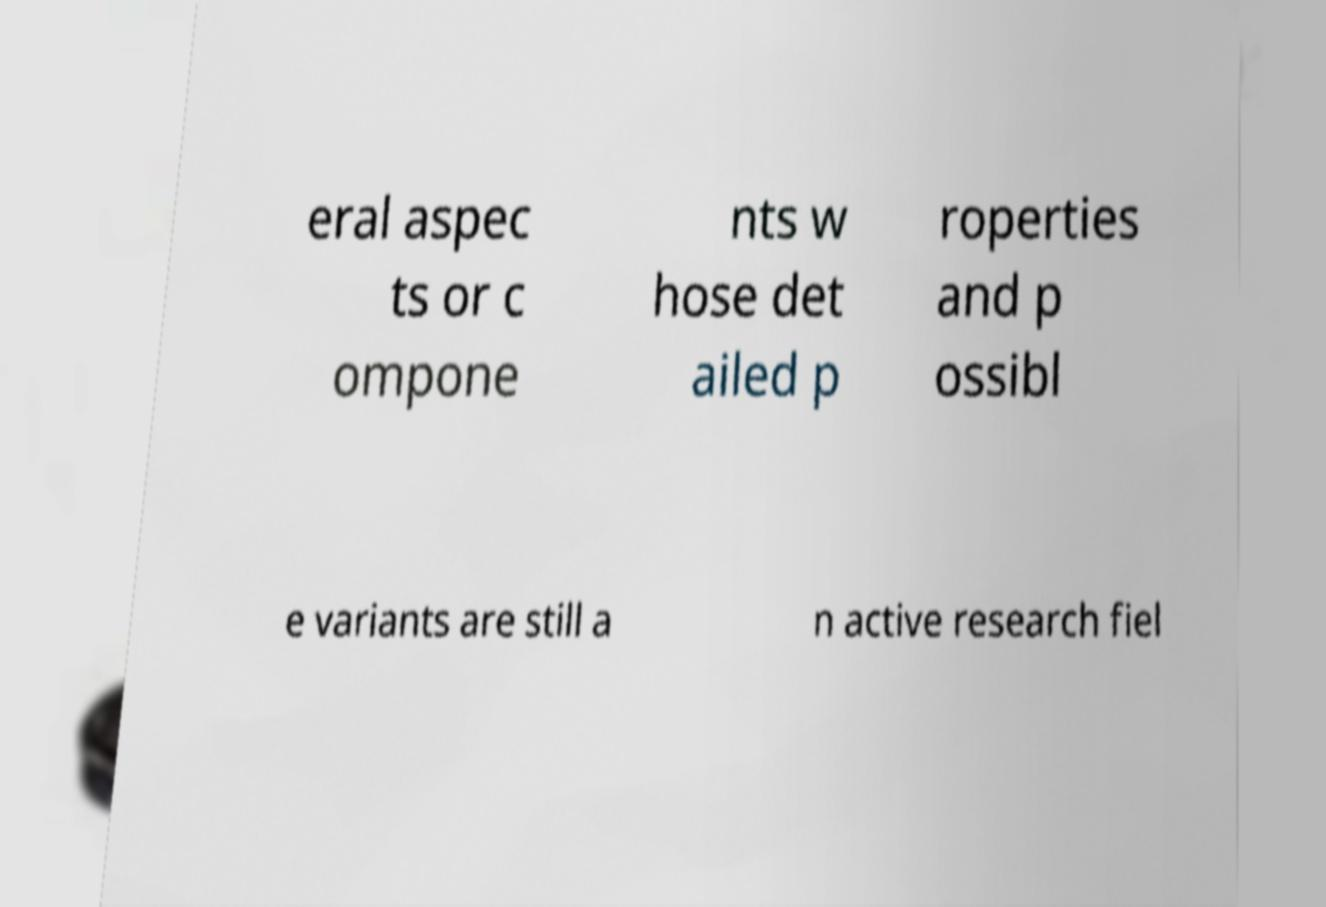Can you accurately transcribe the text from the provided image for me? eral aspec ts or c ompone nts w hose det ailed p roperties and p ossibl e variants are still a n active research fiel 